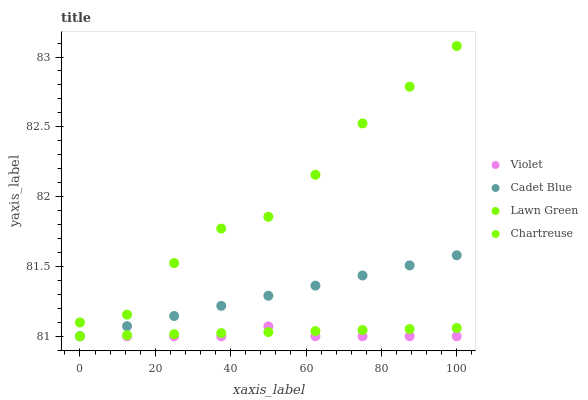Does Violet have the minimum area under the curve?
Answer yes or no. Yes. Does Lawn Green have the maximum area under the curve?
Answer yes or no. Yes. Does Chartreuse have the minimum area under the curve?
Answer yes or no. No. Does Chartreuse have the maximum area under the curve?
Answer yes or no. No. Is Chartreuse the smoothest?
Answer yes or no. Yes. Is Lawn Green the roughest?
Answer yes or no. Yes. Is Cadet Blue the smoothest?
Answer yes or no. No. Is Cadet Blue the roughest?
Answer yes or no. No. Does Chartreuse have the lowest value?
Answer yes or no. Yes. Does Lawn Green have the highest value?
Answer yes or no. Yes. Does Cadet Blue have the highest value?
Answer yes or no. No. Is Cadet Blue less than Lawn Green?
Answer yes or no. Yes. Is Lawn Green greater than Cadet Blue?
Answer yes or no. Yes. Does Cadet Blue intersect Violet?
Answer yes or no. Yes. Is Cadet Blue less than Violet?
Answer yes or no. No. Is Cadet Blue greater than Violet?
Answer yes or no. No. Does Cadet Blue intersect Lawn Green?
Answer yes or no. No. 